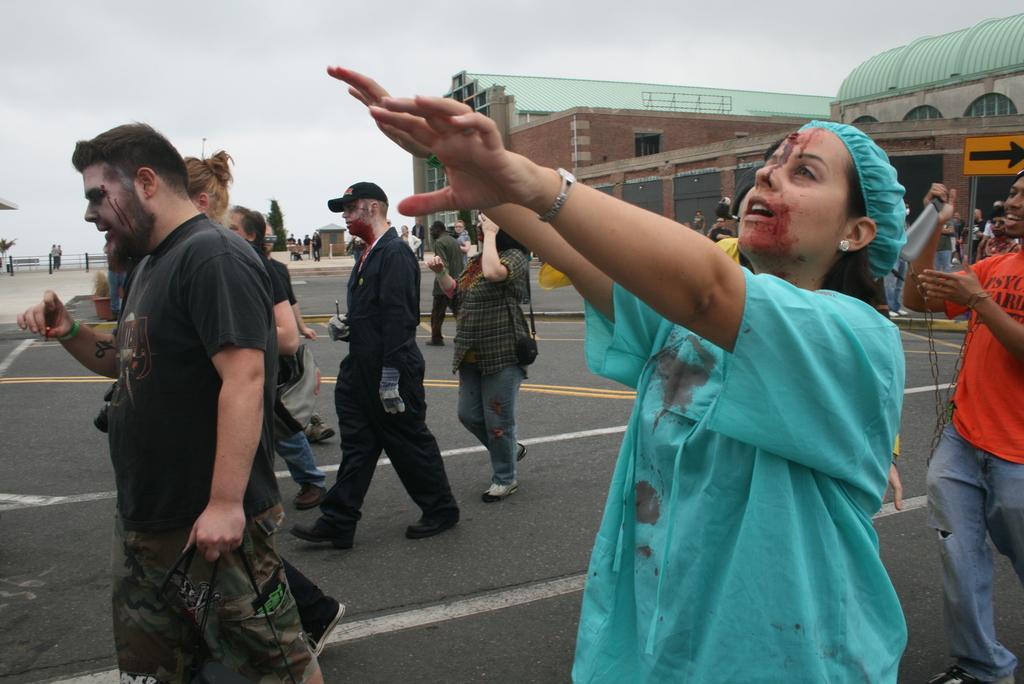Can you describe this image briefly? In this picture we can see some people are walking, on the right side there are buildings and a signboard, in the background we can see a tree and a railing, there is the sky at the top of the picture. 